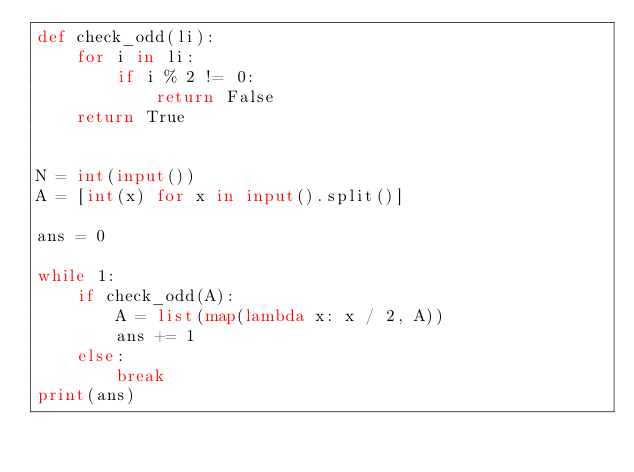<code> <loc_0><loc_0><loc_500><loc_500><_Python_>def check_odd(li):
    for i in li:
        if i % 2 != 0:
            return False
    return True


N = int(input())
A = [int(x) for x in input().split()]

ans = 0

while 1:
    if check_odd(A):
        A = list(map(lambda x: x / 2, A))
        ans += 1
    else:
        break
print(ans)</code> 